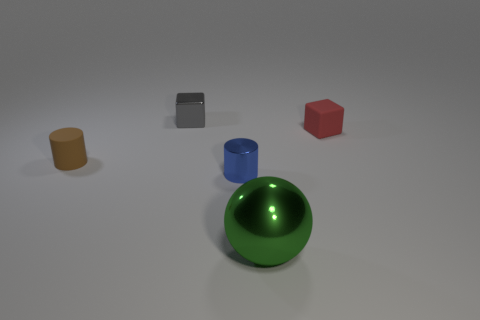Add 4 red rubber cubes. How many objects exist? 9 Subtract all cylinders. How many objects are left? 3 Subtract 0 green cylinders. How many objects are left? 5 Subtract all brown matte things. Subtract all purple objects. How many objects are left? 4 Add 2 green balls. How many green balls are left? 3 Add 2 brown cylinders. How many brown cylinders exist? 3 